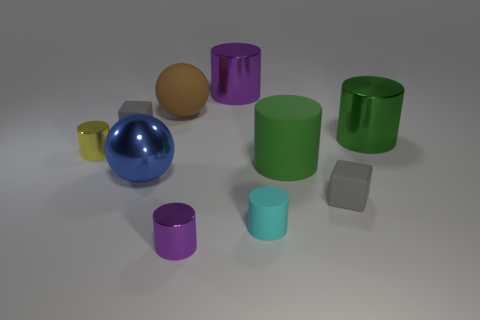Subtract all green cylinders. How many cylinders are left? 4 Subtract all tiny cyan cylinders. How many cylinders are left? 5 Subtract all red cylinders. Subtract all yellow spheres. How many cylinders are left? 6 Subtract all cubes. How many objects are left? 8 Add 9 metallic spheres. How many metallic spheres are left? 10 Add 4 big red metallic cylinders. How many big red metallic cylinders exist? 4 Subtract 0 red cylinders. How many objects are left? 10 Subtract all matte blocks. Subtract all gray blocks. How many objects are left? 6 